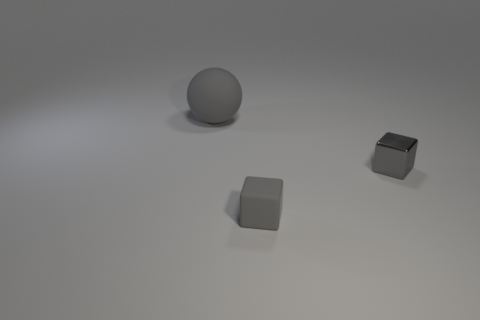There is a tiny gray matte thing; how many small blocks are right of it?
Offer a terse response. 1. How big is the gray thing behind the object to the right of the gray matte thing that is to the right of the large rubber object?
Your answer should be compact. Large. There is a gray rubber thing on the right side of the gray matte sphere to the left of the small matte thing; are there any matte objects that are left of it?
Make the answer very short. Yes. Are there more small blocks than spheres?
Give a very brief answer. Yes. There is a rubber thing that is in front of the gray ball; what is its color?
Your answer should be compact. Gray. Are there more objects that are to the right of the large gray thing than large cyan spheres?
Keep it short and to the point. Yes. What number of other objects are there of the same shape as the large gray matte thing?
Your answer should be compact. 0. What color is the rubber thing that is on the left side of the tiny block that is in front of the tiny cube that is behind the gray matte cube?
Ensure brevity in your answer.  Gray. There is a small gray object that is behind the tiny gray matte object; is its shape the same as the small gray rubber object?
Make the answer very short. Yes. How many matte things are there?
Offer a very short reply. 2. 